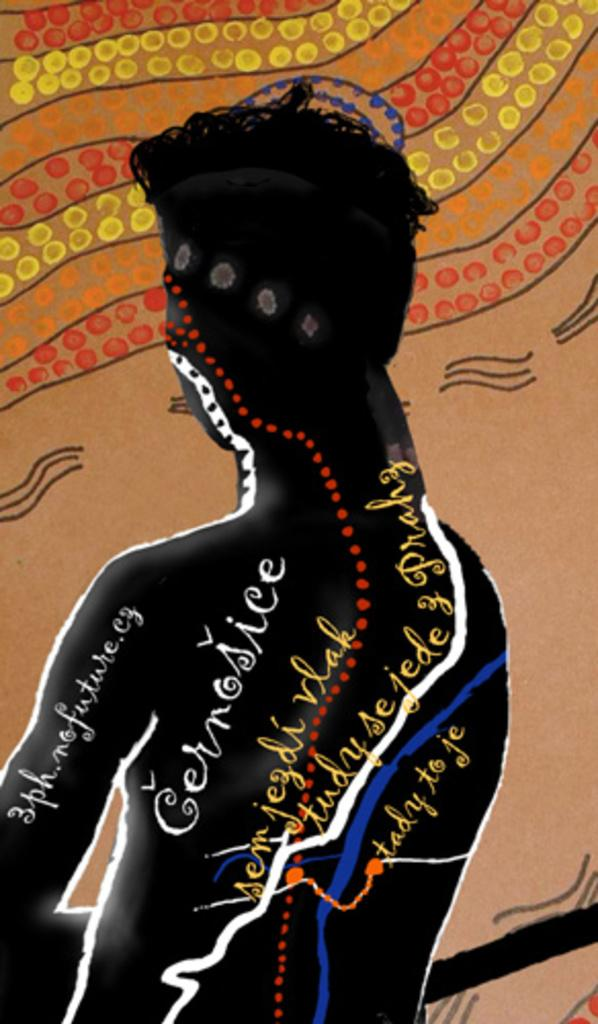What is the main subject of the image? The main subject of the image is a painting. Are there any other elements in the image besides the painting? Yes, there is a person and some text in the image. What type of flesh can be seen in the image? There is no flesh visible in the image; it features a painting, a person, and some text. 